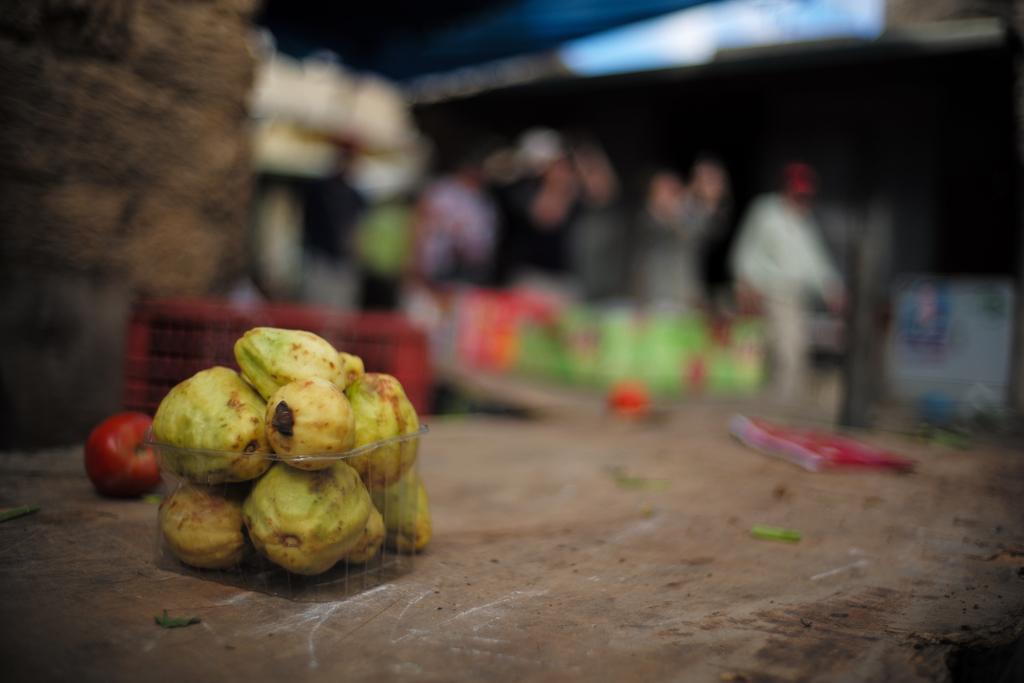Can you describe this image briefly? In the image there are few guavas in the foreground and the background of the guayabas is blur. 